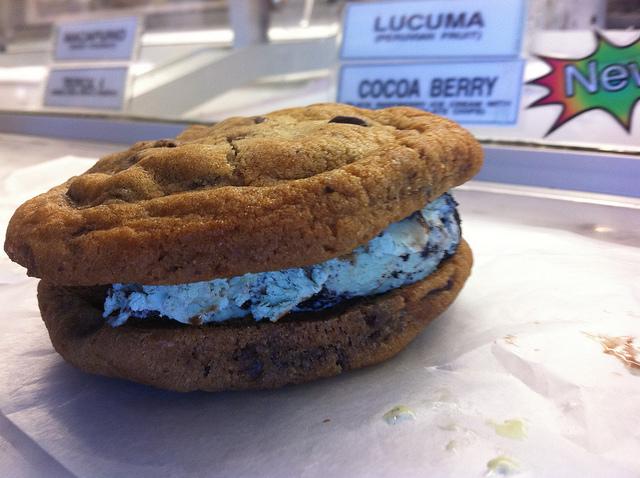Is this healthy?
Be succinct. No. What would you call this treat?
Concise answer only. Ice cream sandwich. What color is the ice cream?
Quick response, please. White. 